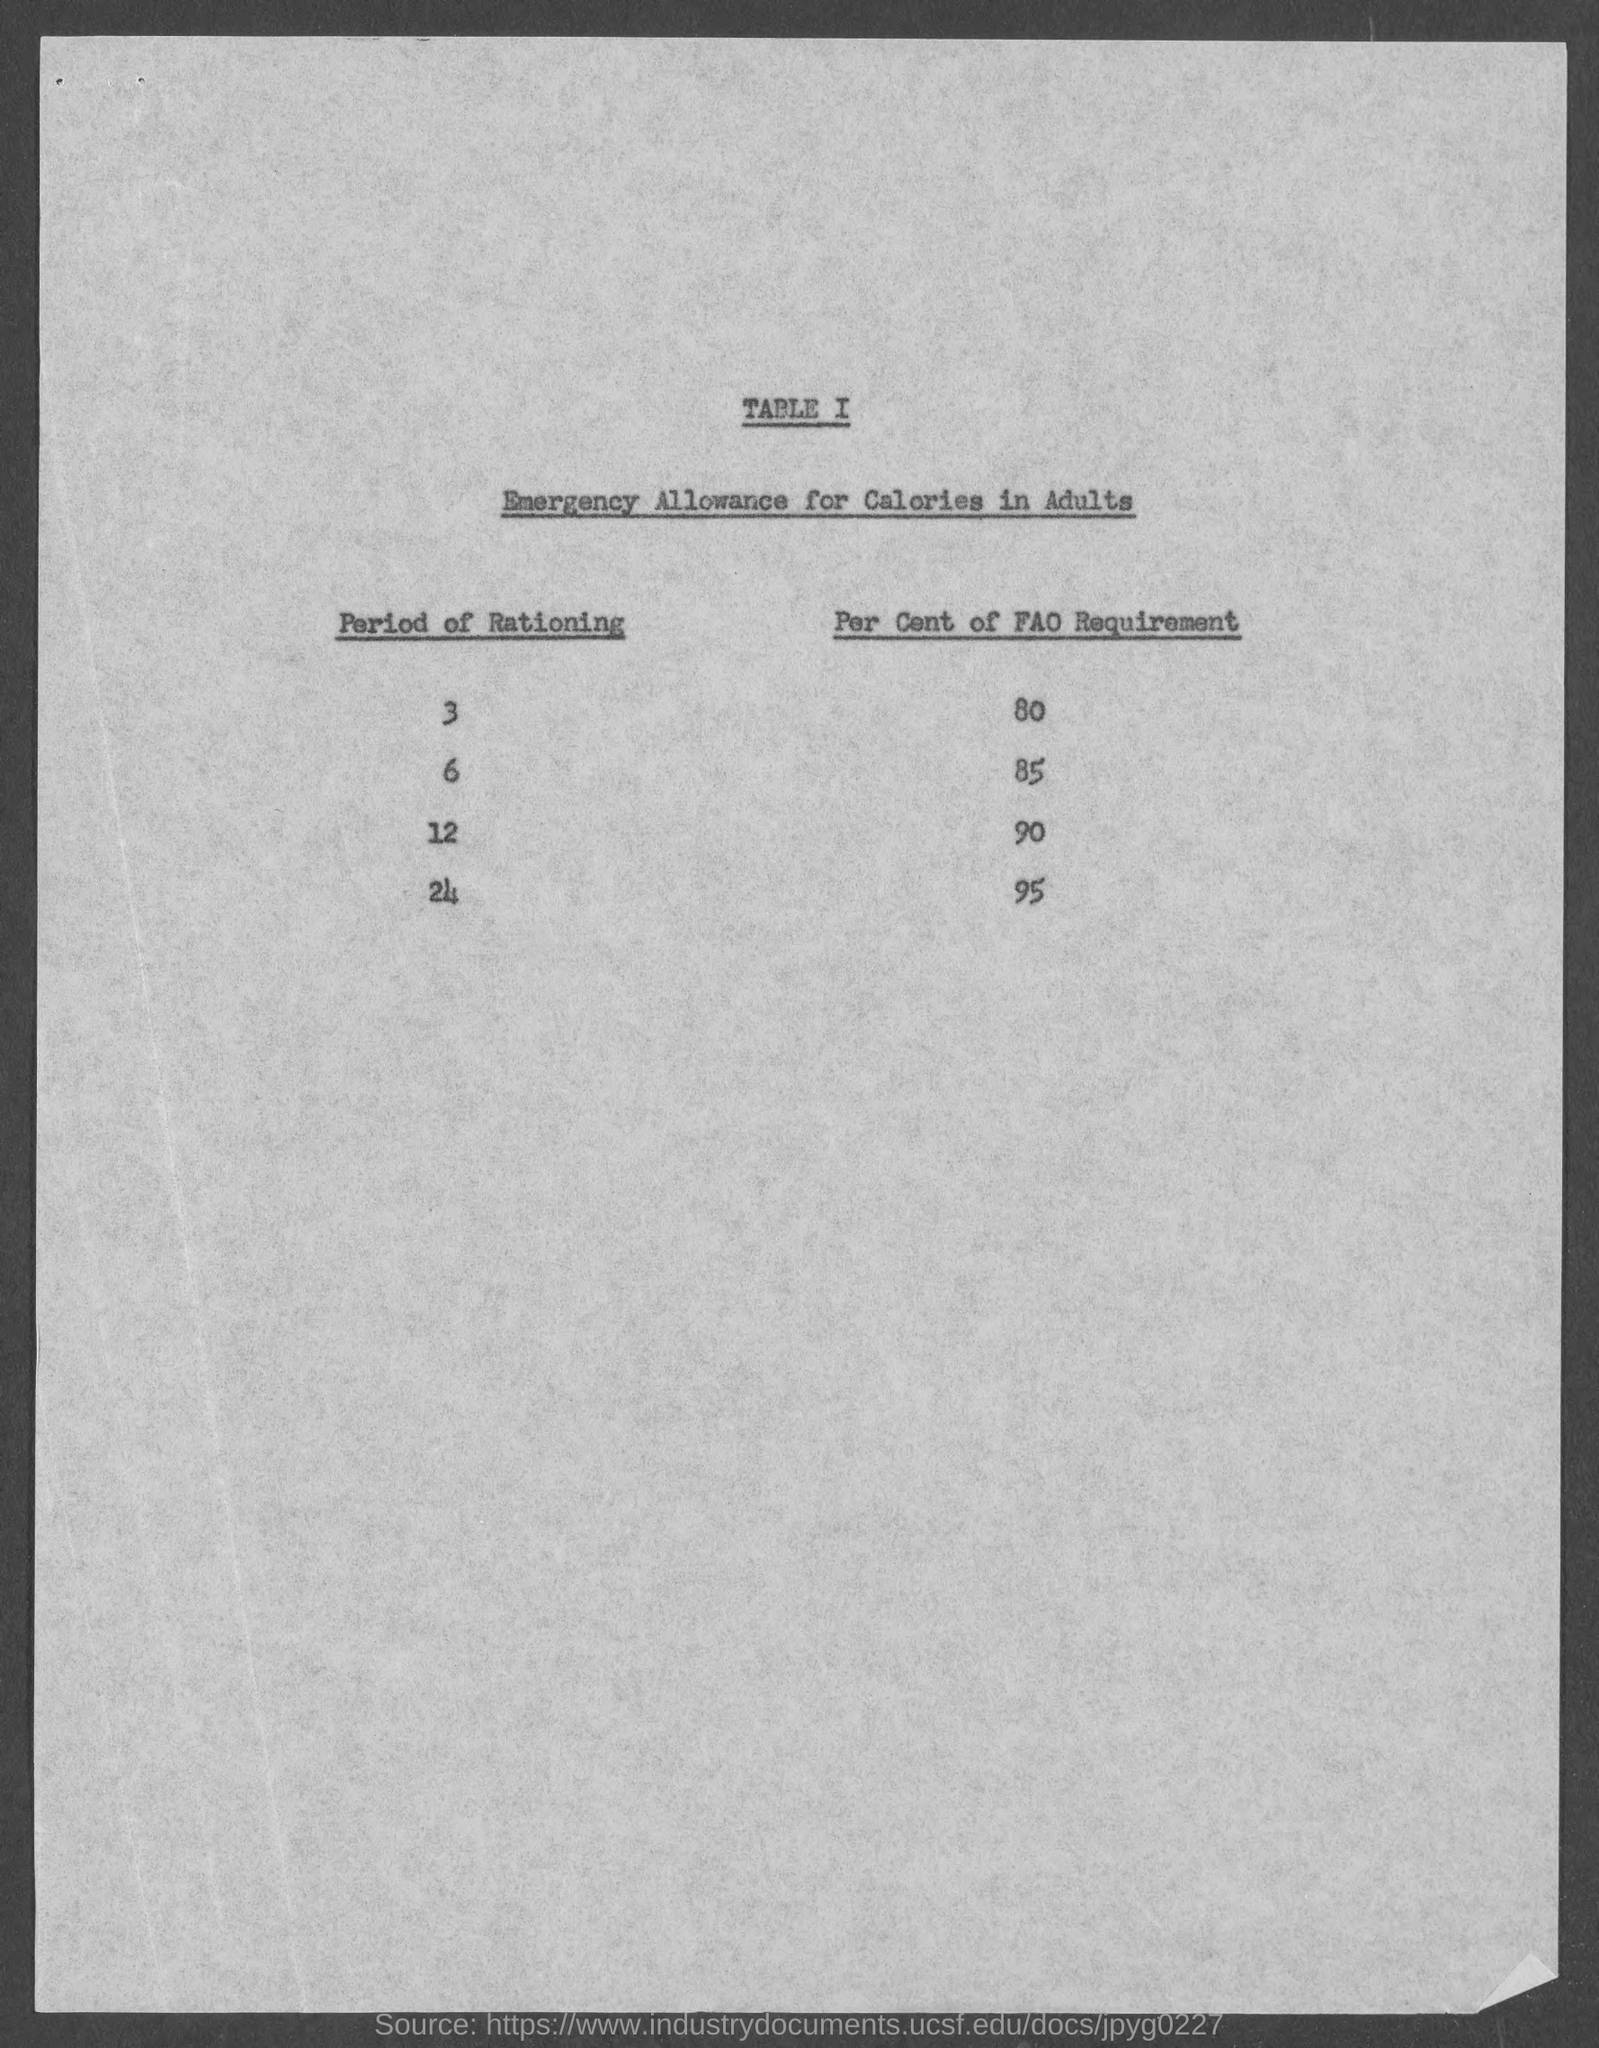What is the title of TABLE I?
Provide a succinct answer. Emergency allowance for calories in adults. 